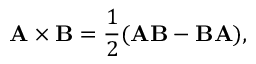Convert formula to latex. <formula><loc_0><loc_0><loc_500><loc_500>A \times B = { \frac { 1 } { 2 } } ( A B - B A ) ,</formula> 